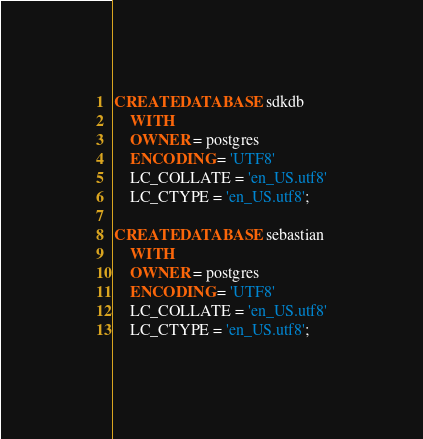Convert code to text. <code><loc_0><loc_0><loc_500><loc_500><_SQL_>CREATE DATABASE sdkdb
    WITH
    OWNER = postgres
    ENCODING = 'UTF8'
    LC_COLLATE = 'en_US.utf8'
    LC_CTYPE = 'en_US.utf8';

CREATE DATABASE sebastian
    WITH
    OWNER = postgres
    ENCODING = 'UTF8'
    LC_COLLATE = 'en_US.utf8'
    LC_CTYPE = 'en_US.utf8';</code> 